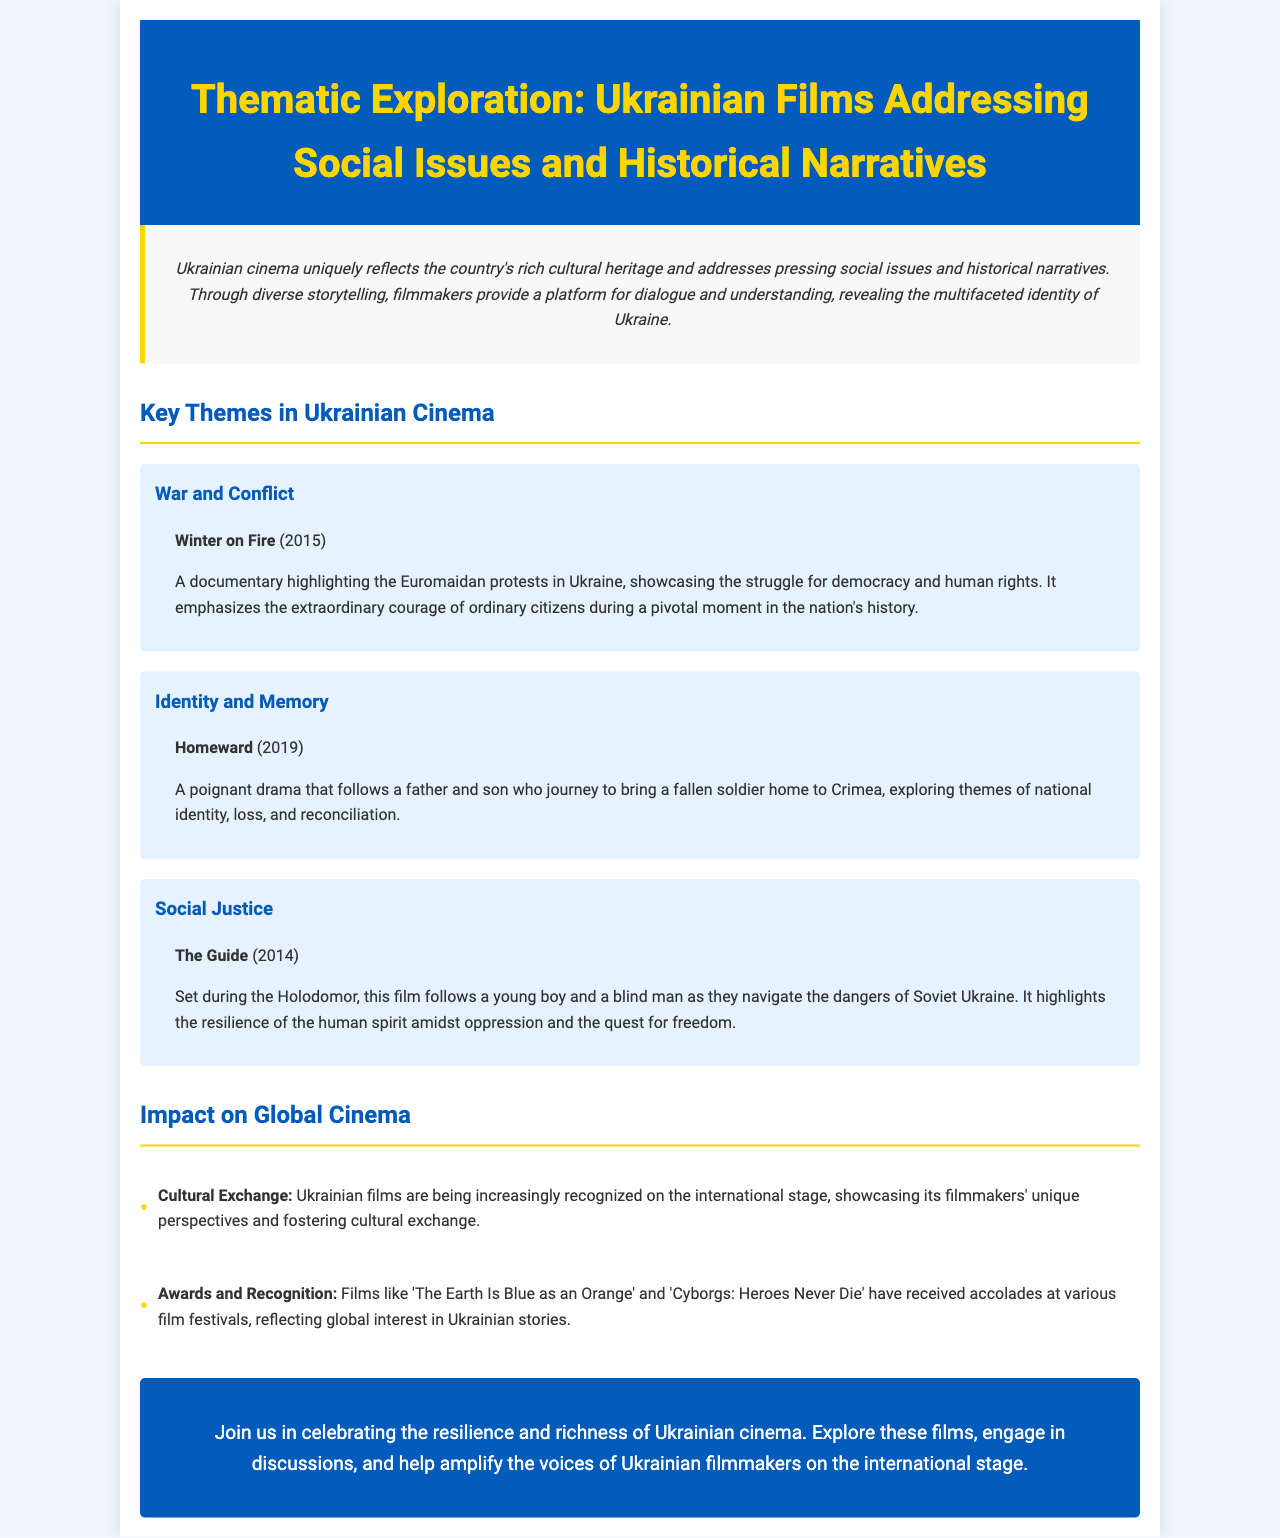What is the title of the brochure? The title is prominently displayed at the top of the document, indicating its focus on thematic exploration in Ukrainian cinema.
Answer: Thematic Exploration: Ukrainian Films Addressing Social Issues and Historical Narratives Which film highlights the Euromaidan protests? The document identifies specific films within thematic sections, naming 'Winter on Fire' as one that focuses on the Euromaidan protests.
Answer: Winter on Fire What year was 'Homeward' released? The year of release for each film is mentioned alongside its title, with 'Homeward' being released in 2019.
Answer: 2019 What theme does 'The Guide' address? The theme of each film is explicitly stated in the related theme section, with 'The Guide' addressing social justice.
Answer: Social Justice Which theme includes a story about a father and son? The document categorizes films under themes, noting that 'Homeward' features a father and son journey.
Answer: Identity and Memory How many impact points are discussed? The number of impact points is specified in the corresponding section, with two main points listed.
Answer: 2 What does the brochure encourage readers to do? The call to action within the document prompts readers to engage and promote Ukrainian cinema.
Answer: Celebrate the resilience and richness of Ukrainian cinema Which acclaimed film is mentioned for its awards? The document specifies 'The Earth Is Blue as an Orange' as one of the films that received accolades.
Answer: The Earth Is Blue as an Orange 